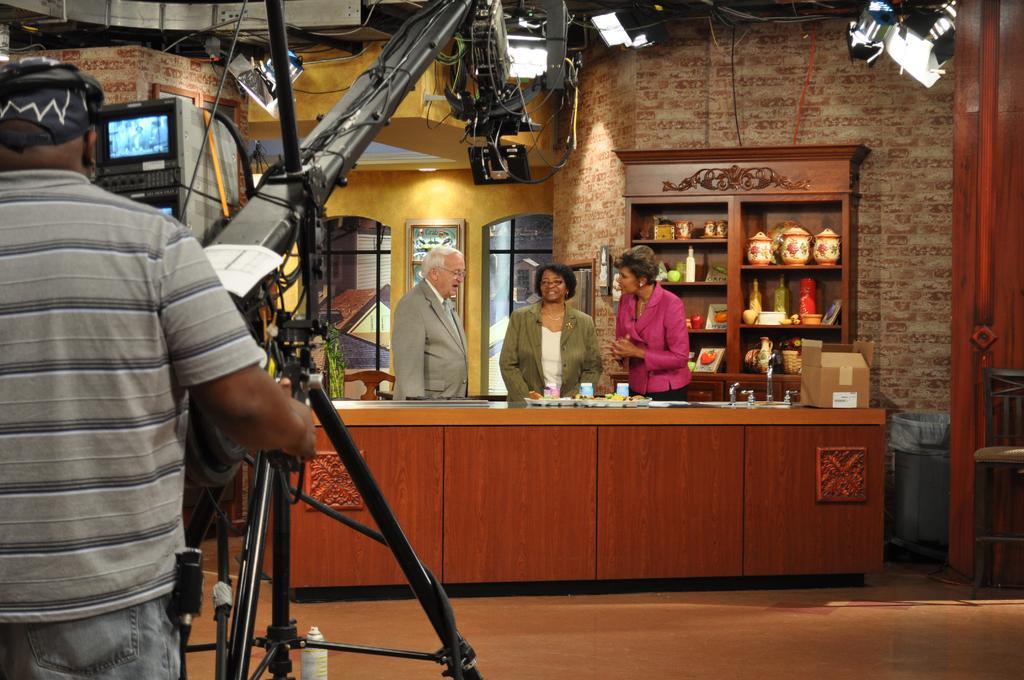Could you give a brief overview of what you see in this image? On the left side of the image there is a man standing and holding a stand and we can see rod, cables and camera. We can see bottle and floor. In the background of the image there are three people standing and we can see card board box and objects on the table, televisions, windows, objects in racks, frame on the wall, chair, lights and dustbin. 